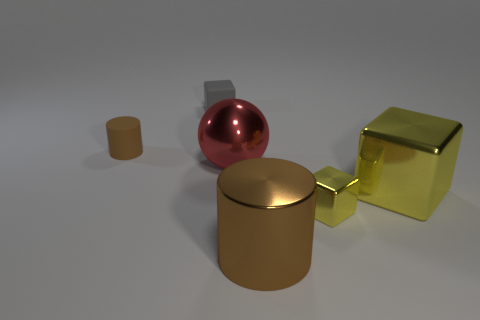Is there anything else that has the same shape as the red metallic thing?
Keep it short and to the point. No. Are there any other small cylinders of the same color as the shiny cylinder?
Make the answer very short. Yes. Is the size of the brown metallic cylinder the same as the gray matte cube?
Provide a short and direct response. No. Do the rubber cylinder and the large cylinder have the same color?
Your answer should be very brief. Yes. There is a brown object that is in front of the tiny thing that is in front of the metallic ball; what is its material?
Provide a succinct answer. Metal. What is the material of the large yellow thing that is the same shape as the small gray object?
Offer a very short reply. Metal. There is a cylinder that is right of the red ball; does it have the same size as the tiny yellow metallic thing?
Offer a terse response. No. How many matte things are large balls or big yellow blocks?
Provide a succinct answer. 0. The large object that is both in front of the big red thing and behind the brown metal cylinder is made of what material?
Your answer should be compact. Metal. Do the tiny gray thing and the tiny brown cylinder have the same material?
Provide a short and direct response. Yes. 